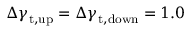<formula> <loc_0><loc_0><loc_500><loc_500>\Delta \gamma _ { t , u p } = \Delta \gamma _ { t , d o w n } = 1 . 0</formula> 